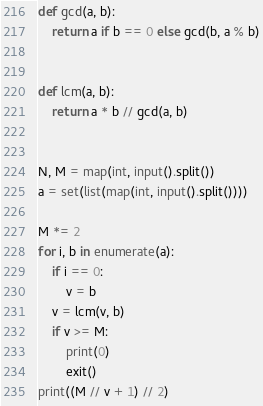<code> <loc_0><loc_0><loc_500><loc_500><_Python_>def gcd(a, b):
    return a if b == 0 else gcd(b, a % b)


def lcm(a, b):
    return a * b // gcd(a, b)


N, M = map(int, input().split())
a = set(list(map(int, input().split())))

M *= 2
for i, b in enumerate(a):
    if i == 0:
        v = b
    v = lcm(v, b)
    if v >= M:
        print(0)
        exit()
print((M // v + 1) // 2)
</code> 